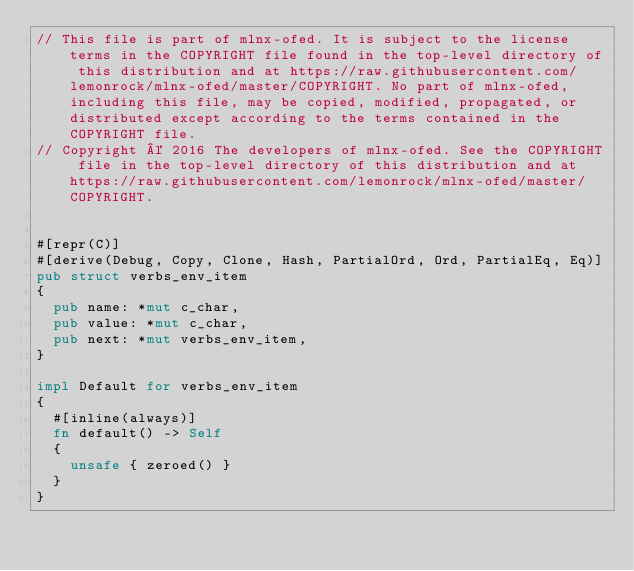Convert code to text. <code><loc_0><loc_0><loc_500><loc_500><_Rust_>// This file is part of mlnx-ofed. It is subject to the license terms in the COPYRIGHT file found in the top-level directory of this distribution and at https://raw.githubusercontent.com/lemonrock/mlnx-ofed/master/COPYRIGHT. No part of mlnx-ofed, including this file, may be copied, modified, propagated, or distributed except according to the terms contained in the COPYRIGHT file.
// Copyright © 2016 The developers of mlnx-ofed. See the COPYRIGHT file in the top-level directory of this distribution and at https://raw.githubusercontent.com/lemonrock/mlnx-ofed/master/COPYRIGHT.


#[repr(C)]
#[derive(Debug, Copy, Clone, Hash, PartialOrd, Ord, PartialEq, Eq)]
pub struct verbs_env_item
{
	pub name: *mut c_char,
	pub value: *mut c_char,
	pub next: *mut verbs_env_item,
}

impl Default for verbs_env_item
{
	#[inline(always)]
	fn default() -> Self
	{
		unsafe { zeroed() }
	}
}
</code> 